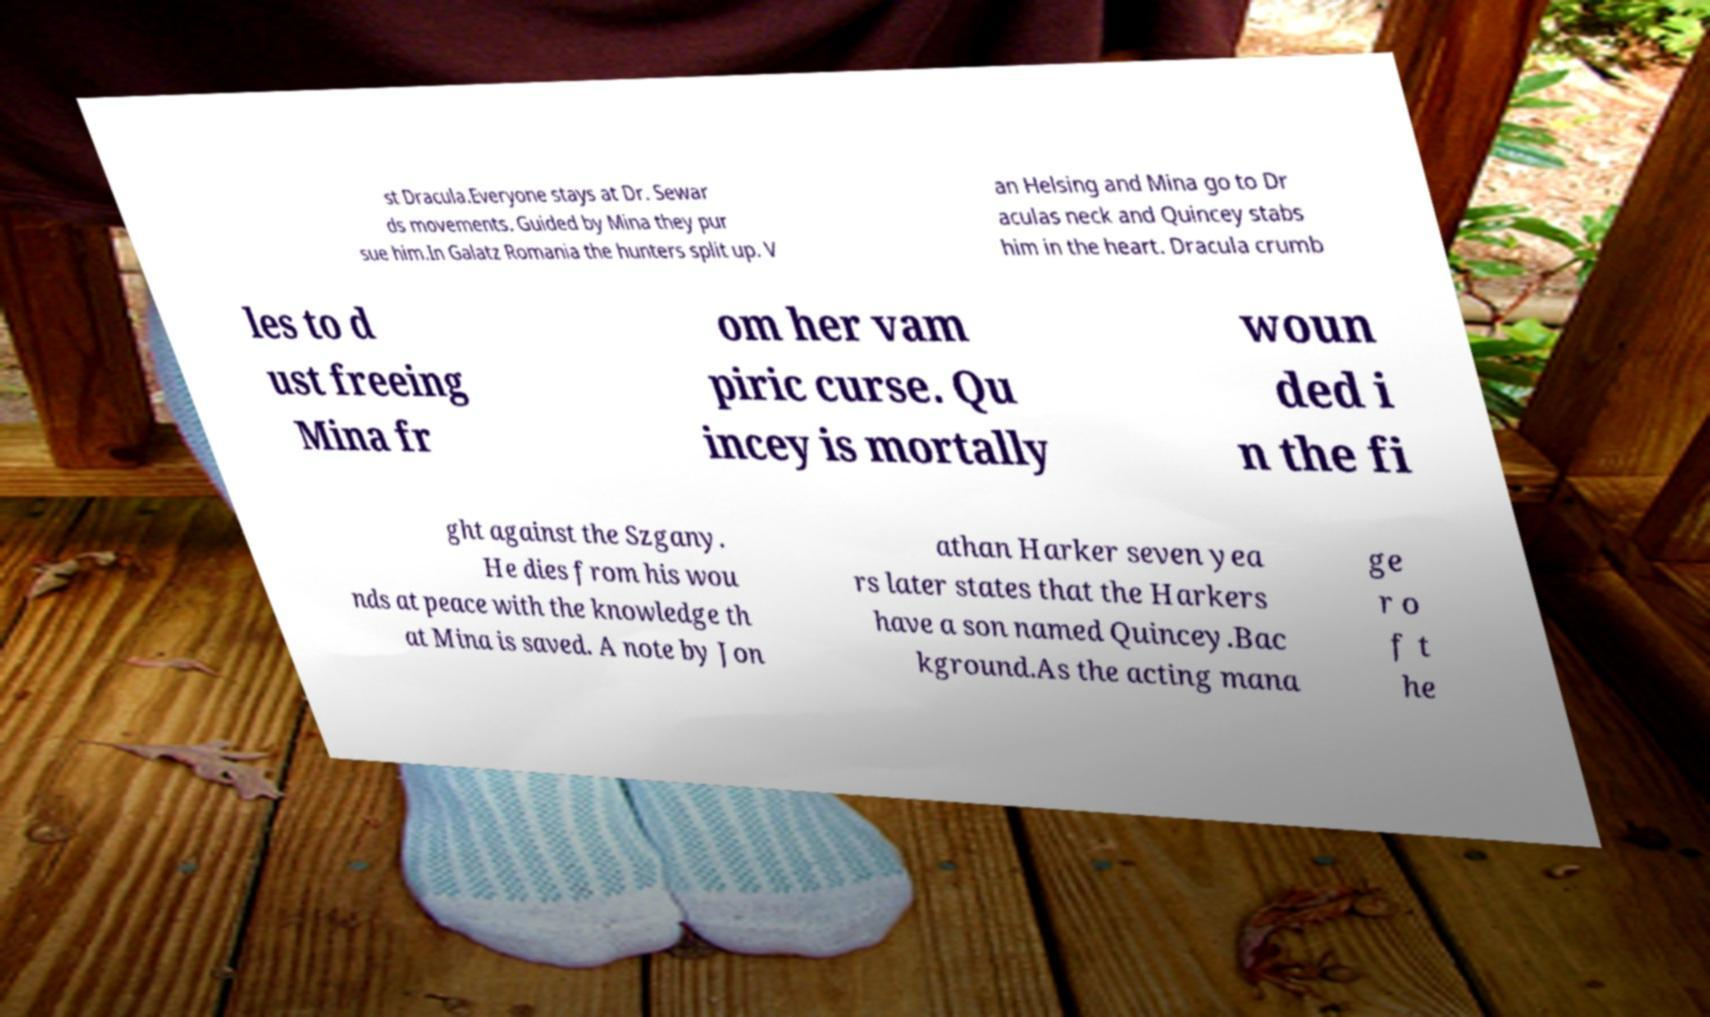Could you extract and type out the text from this image? st Dracula.Everyone stays at Dr. Sewar ds movements. Guided by Mina they pur sue him.In Galatz Romania the hunters split up. V an Helsing and Mina go to Dr aculas neck and Quincey stabs him in the heart. Dracula crumb les to d ust freeing Mina fr om her vam piric curse. Qu incey is mortally woun ded i n the fi ght against the Szgany. He dies from his wou nds at peace with the knowledge th at Mina is saved. A note by Jon athan Harker seven yea rs later states that the Harkers have a son named Quincey.Bac kground.As the acting mana ge r o f t he 